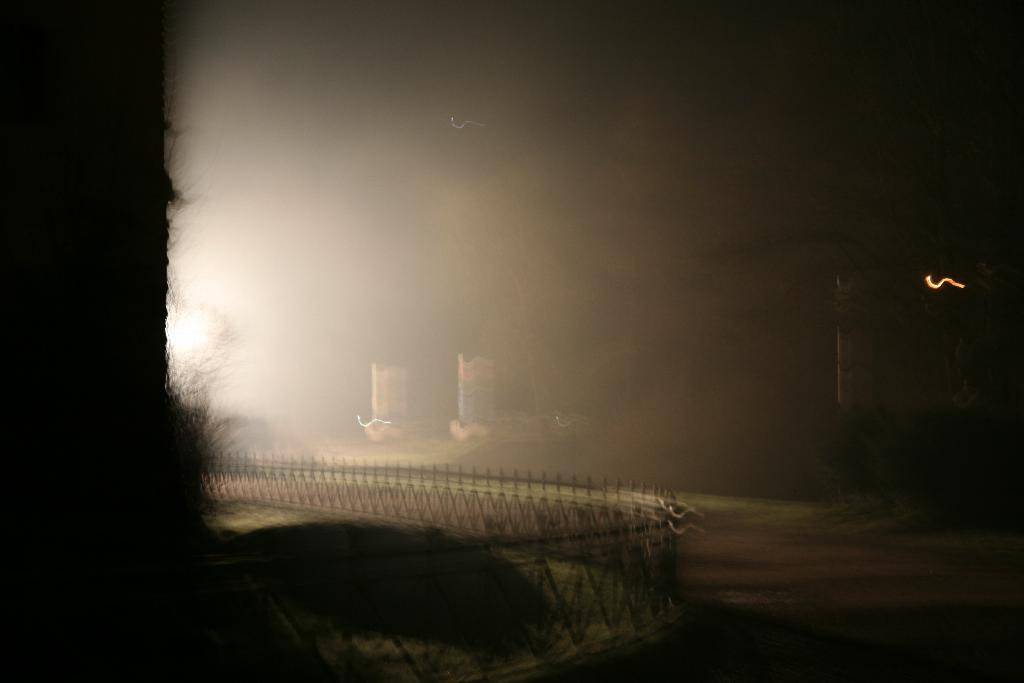What type of structure is present in the image? There is a building in the image. What is located at the bottom of the image? There is fencing and plants at the bottom of the image. What can be seen in the background of the image? There are trees visible in the background of the image. What type of pain is being experienced by the skate in the image? There is no skate present in the image, so it is not possible to determine if any pain is being experienced. 